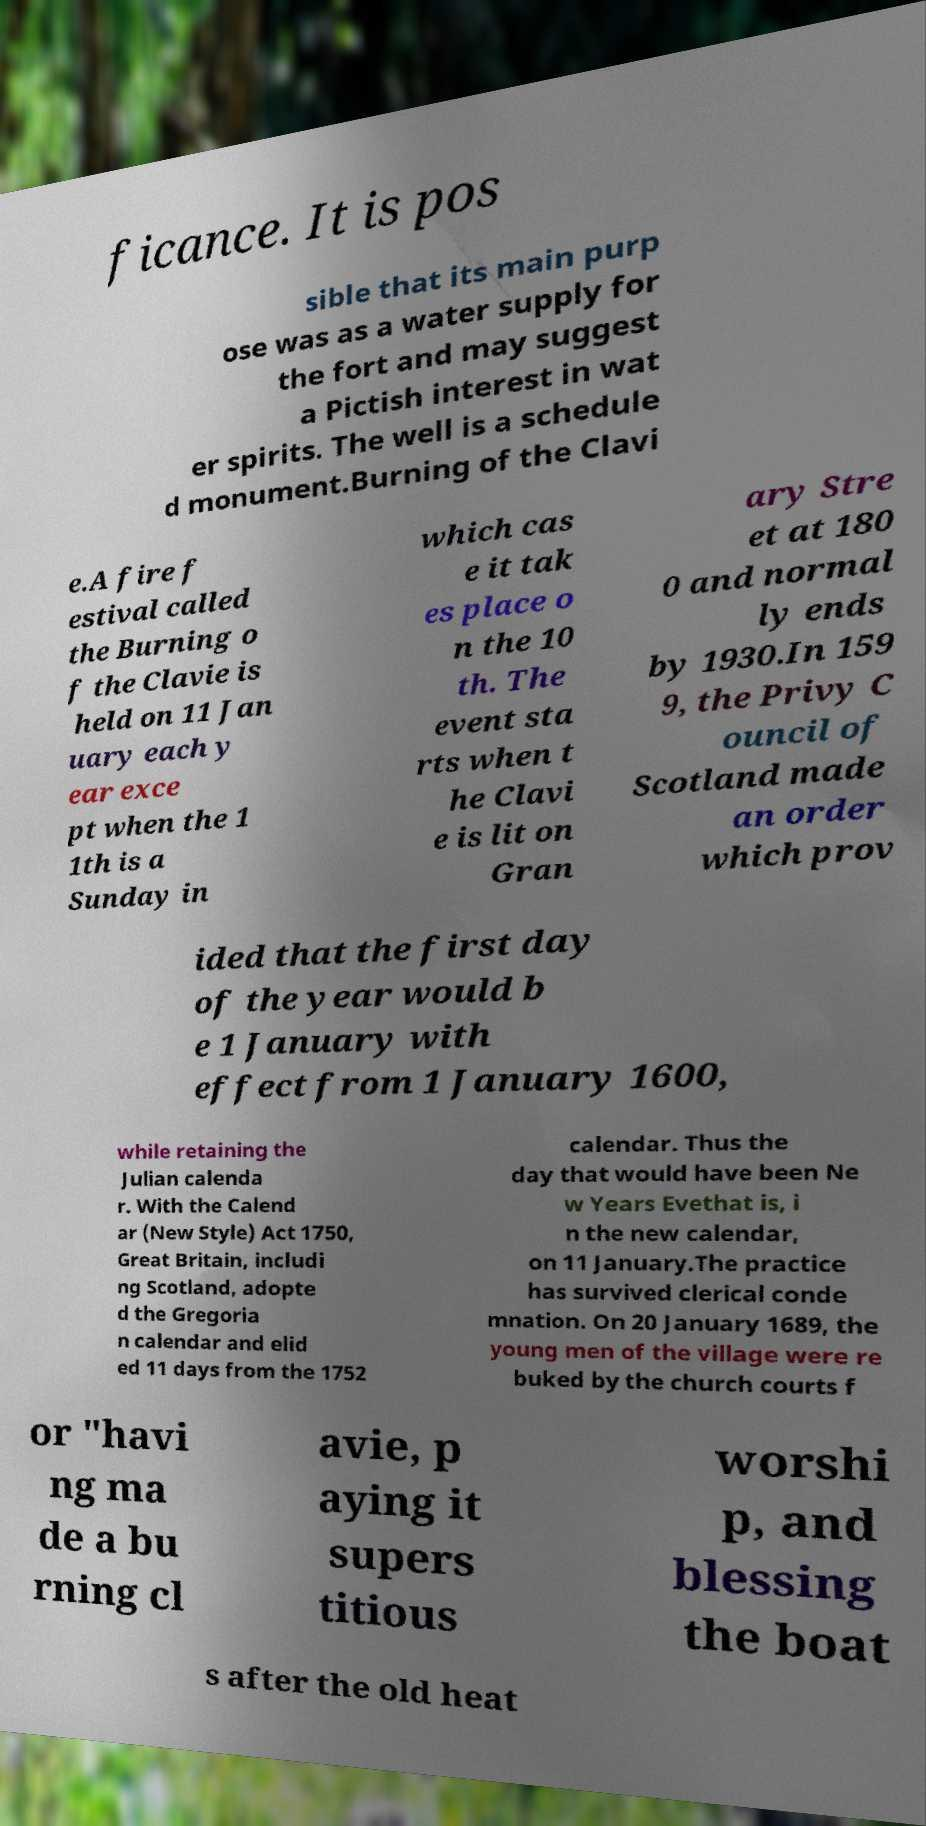Could you extract and type out the text from this image? ficance. It is pos sible that its main purp ose was as a water supply for the fort and may suggest a Pictish interest in wat er spirits. The well is a schedule d monument.Burning of the Clavi e.A fire f estival called the Burning o f the Clavie is held on 11 Jan uary each y ear exce pt when the 1 1th is a Sunday in which cas e it tak es place o n the 10 th. The event sta rts when t he Clavi e is lit on Gran ary Stre et at 180 0 and normal ly ends by 1930.In 159 9, the Privy C ouncil of Scotland made an order which prov ided that the first day of the year would b e 1 January with effect from 1 January 1600, while retaining the Julian calenda r. With the Calend ar (New Style) Act 1750, Great Britain, includi ng Scotland, adopte d the Gregoria n calendar and elid ed 11 days from the 1752 calendar. Thus the day that would have been Ne w Years Evethat is, i n the new calendar, on 11 January.The practice has survived clerical conde mnation. On 20 January 1689, the young men of the village were re buked by the church courts f or "havi ng ma de a bu rning cl avie, p aying it supers titious worshi p, and blessing the boat s after the old heat 